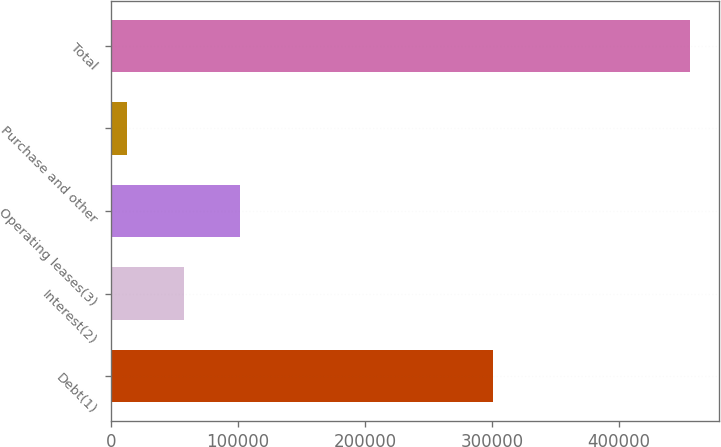<chart> <loc_0><loc_0><loc_500><loc_500><bar_chart><fcel>Debt(1)<fcel>Interest(2)<fcel>Operating leases(3)<fcel>Purchase and other<fcel>Total<nl><fcel>301114<fcel>57438.9<fcel>101724<fcel>13154<fcel>456003<nl></chart> 